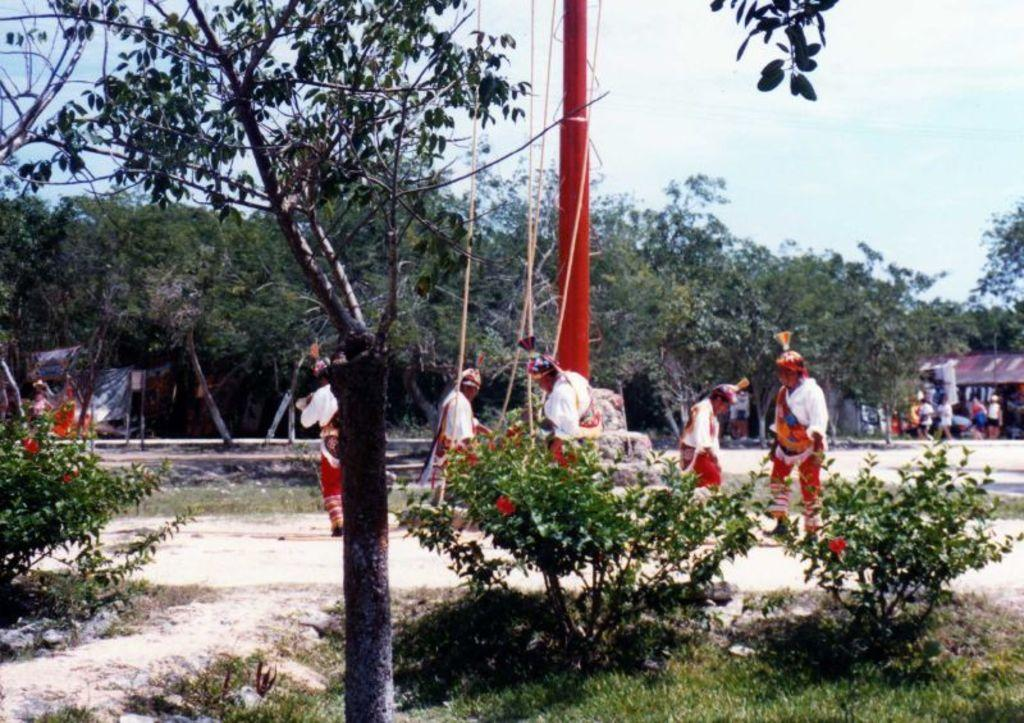What are the people in the image doing? The people in the image are walking on the ground. What object can be seen with thread in the image? There is a pole with thread in the image. What type of vegetation is present in the image? There are trees in the image. What type of structure can be seen in the image? There is a shed and a building in the image. What is visible in the background of the image? The sky is visible in the image. Can you describe the lake in the image? There is no lake present in the image. What type of dress is the person wearing in the image? There is no person wearing a dress in the image; the people are walking on the ground. 